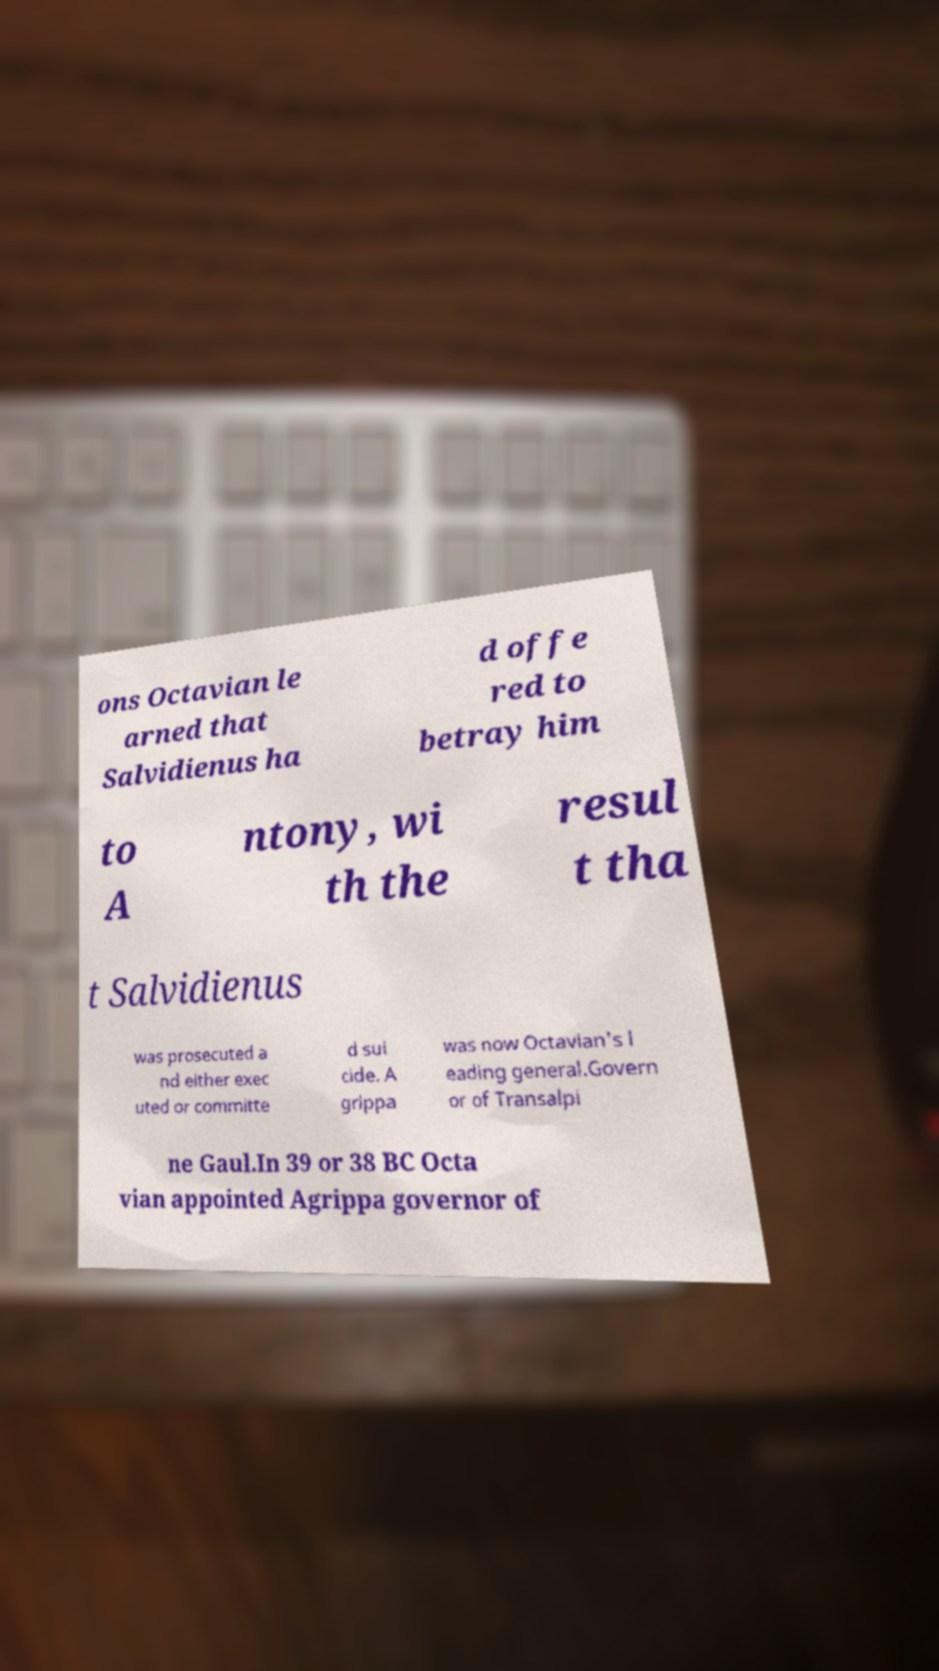Could you extract and type out the text from this image? ons Octavian le arned that Salvidienus ha d offe red to betray him to A ntony, wi th the resul t tha t Salvidienus was prosecuted a nd either exec uted or committe d sui cide. A grippa was now Octavian's l eading general.Govern or of Transalpi ne Gaul.In 39 or 38 BC Octa vian appointed Agrippa governor of 